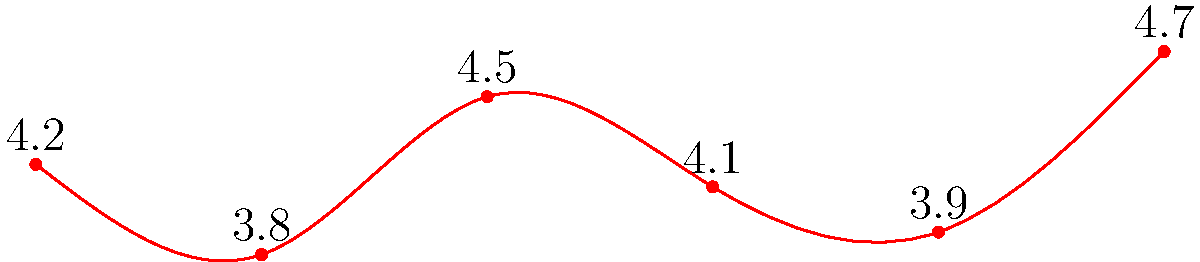Based on the bar graph showing customer satisfaction ratings for various medical products, which product would you recommend to a hospital looking to maximize patient satisfaction with their medical equipment? To answer this question, we need to analyze the customer satisfaction ratings for each product:

1. Product A: 4.2
2. Product B: 3.8
3. Product C: 4.5
4. Product D: 4.1
5. Product E: 3.9
6. Product F: 4.7

Step 1: Identify the highest rating
The highest customer satisfaction rating is 4.7, corresponding to Product F.

Step 2: Consider the context
As a sales representative, our goal is to ensure that the company's products meet the hospital's needs and specifications. In this case, the hospital is looking to maximize patient satisfaction with their medical equipment.

Step 3: Make the recommendation
Since Product F has the highest customer satisfaction rating (4.7), it would be the best recommendation for the hospital to maximize patient satisfaction with their medical equipment.

Step 4: Consider additional factors (optional)
While not explicitly asked in the question, it's worth noting that Product C (4.5) and Product A (4.2) also have relatively high satisfaction ratings. These could be mentioned as alternative options if Product F doesn't meet other specific requirements of the hospital.
Answer: Product F 